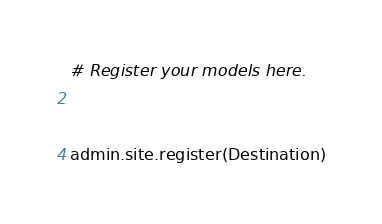Convert code to text. <code><loc_0><loc_0><loc_500><loc_500><_Python_># Register your models here.


admin.site.register(Destination)</code> 